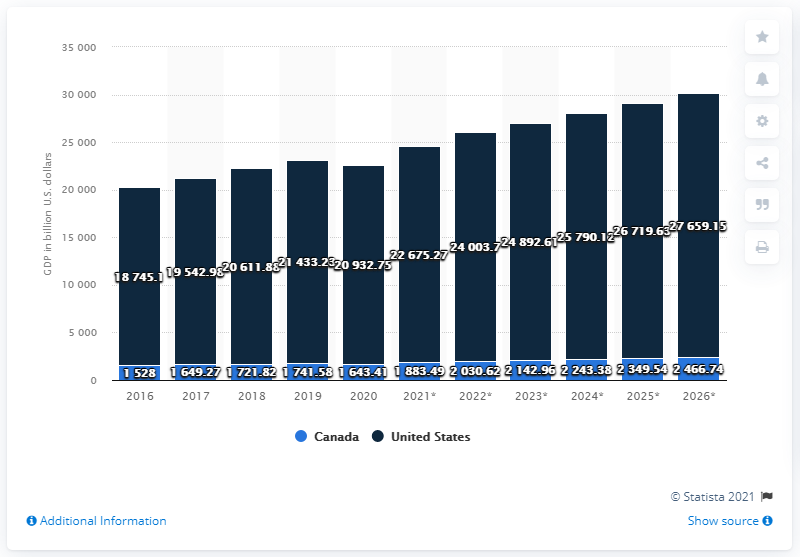Outline some significant characteristics in this image. In 2020, the Gross Domestic Product (GDP) of North America was valued at approximately 209,327.5 dollars. In 2020, the Gross Domestic Product (GDP) of Canada was 1643.41 billion dollars. In 2020, the GDP of the United States was 21,433.23 dollars. 